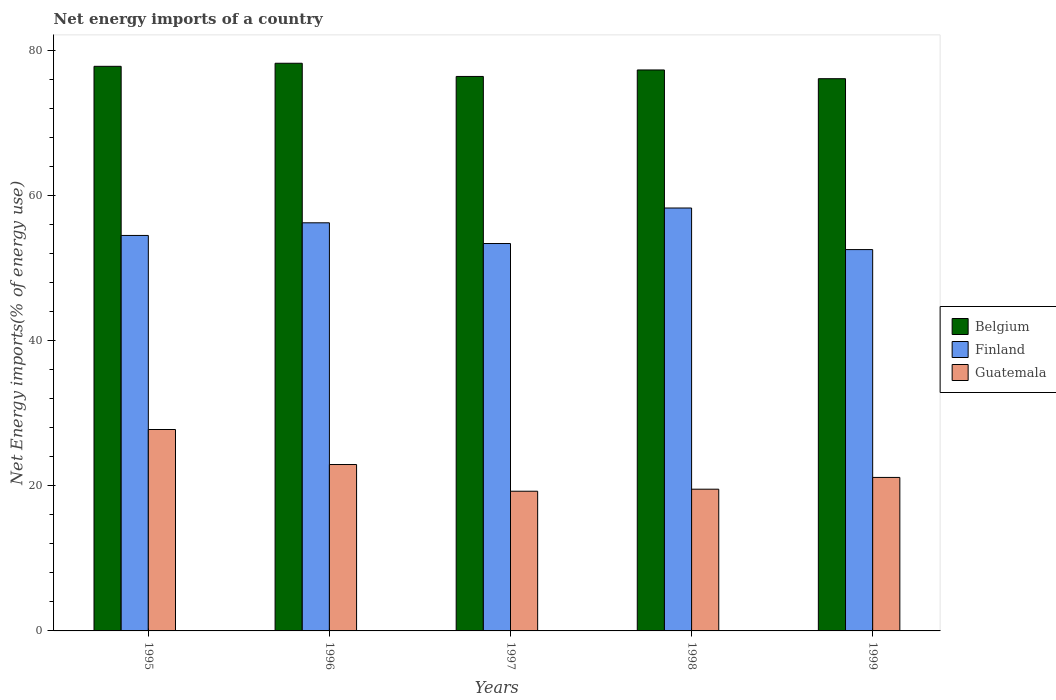Are the number of bars per tick equal to the number of legend labels?
Offer a terse response. Yes. Are the number of bars on each tick of the X-axis equal?
Offer a very short reply. Yes. How many bars are there on the 3rd tick from the left?
Offer a very short reply. 3. How many bars are there on the 5th tick from the right?
Provide a short and direct response. 3. What is the net energy imports in Guatemala in 1996?
Offer a terse response. 22.93. Across all years, what is the maximum net energy imports in Belgium?
Provide a succinct answer. 78.22. Across all years, what is the minimum net energy imports in Belgium?
Keep it short and to the point. 76.1. In which year was the net energy imports in Belgium maximum?
Ensure brevity in your answer.  1996. In which year was the net energy imports in Finland minimum?
Ensure brevity in your answer.  1999. What is the total net energy imports in Guatemala in the graph?
Your response must be concise. 110.61. What is the difference between the net energy imports in Finland in 1996 and that in 1997?
Offer a very short reply. 2.85. What is the difference between the net energy imports in Belgium in 1998 and the net energy imports in Finland in 1995?
Your answer should be compact. 22.8. What is the average net energy imports in Belgium per year?
Make the answer very short. 77.17. In the year 1998, what is the difference between the net energy imports in Guatemala and net energy imports in Belgium?
Provide a short and direct response. -57.77. In how many years, is the net energy imports in Finland greater than 64 %?
Provide a succinct answer. 0. What is the ratio of the net energy imports in Guatemala in 1998 to that in 1999?
Make the answer very short. 0.92. Is the net energy imports in Guatemala in 1997 less than that in 1998?
Provide a short and direct response. Yes. What is the difference between the highest and the second highest net energy imports in Guatemala?
Make the answer very short. 4.83. What is the difference between the highest and the lowest net energy imports in Belgium?
Your response must be concise. 2.13. Is it the case that in every year, the sum of the net energy imports in Belgium and net energy imports in Guatemala is greater than the net energy imports in Finland?
Give a very brief answer. Yes. Are all the bars in the graph horizontal?
Your response must be concise. No. How many years are there in the graph?
Make the answer very short. 5. What is the difference between two consecutive major ticks on the Y-axis?
Provide a short and direct response. 20. How many legend labels are there?
Provide a succinct answer. 3. What is the title of the graph?
Provide a succinct answer. Net energy imports of a country. What is the label or title of the X-axis?
Give a very brief answer. Years. What is the label or title of the Y-axis?
Make the answer very short. Net Energy imports(% of energy use). What is the Net Energy imports(% of energy use) of Belgium in 1995?
Give a very brief answer. 77.8. What is the Net Energy imports(% of energy use) in Finland in 1995?
Provide a short and direct response. 54.5. What is the Net Energy imports(% of energy use) of Guatemala in 1995?
Provide a succinct answer. 27.76. What is the Net Energy imports(% of energy use) in Belgium in 1996?
Your answer should be compact. 78.22. What is the Net Energy imports(% of energy use) of Finland in 1996?
Your answer should be compact. 56.24. What is the Net Energy imports(% of energy use) of Guatemala in 1996?
Your answer should be compact. 22.93. What is the Net Energy imports(% of energy use) in Belgium in 1997?
Give a very brief answer. 76.41. What is the Net Energy imports(% of energy use) in Finland in 1997?
Give a very brief answer. 53.38. What is the Net Energy imports(% of energy use) of Guatemala in 1997?
Keep it short and to the point. 19.25. What is the Net Energy imports(% of energy use) in Belgium in 1998?
Offer a terse response. 77.3. What is the Net Energy imports(% of energy use) in Finland in 1998?
Your answer should be very brief. 58.28. What is the Net Energy imports(% of energy use) of Guatemala in 1998?
Ensure brevity in your answer.  19.53. What is the Net Energy imports(% of energy use) of Belgium in 1999?
Offer a terse response. 76.1. What is the Net Energy imports(% of energy use) of Finland in 1999?
Make the answer very short. 52.55. What is the Net Energy imports(% of energy use) in Guatemala in 1999?
Offer a terse response. 21.15. Across all years, what is the maximum Net Energy imports(% of energy use) of Belgium?
Keep it short and to the point. 78.22. Across all years, what is the maximum Net Energy imports(% of energy use) of Finland?
Give a very brief answer. 58.28. Across all years, what is the maximum Net Energy imports(% of energy use) of Guatemala?
Your answer should be very brief. 27.76. Across all years, what is the minimum Net Energy imports(% of energy use) of Belgium?
Ensure brevity in your answer.  76.1. Across all years, what is the minimum Net Energy imports(% of energy use) of Finland?
Provide a succinct answer. 52.55. Across all years, what is the minimum Net Energy imports(% of energy use) of Guatemala?
Give a very brief answer. 19.25. What is the total Net Energy imports(% of energy use) in Belgium in the graph?
Ensure brevity in your answer.  385.83. What is the total Net Energy imports(% of energy use) of Finland in the graph?
Provide a short and direct response. 274.94. What is the total Net Energy imports(% of energy use) in Guatemala in the graph?
Offer a very short reply. 110.61. What is the difference between the Net Energy imports(% of energy use) of Belgium in 1995 and that in 1996?
Your response must be concise. -0.42. What is the difference between the Net Energy imports(% of energy use) in Finland in 1995 and that in 1996?
Provide a succinct answer. -1.74. What is the difference between the Net Energy imports(% of energy use) of Guatemala in 1995 and that in 1996?
Make the answer very short. 4.83. What is the difference between the Net Energy imports(% of energy use) in Belgium in 1995 and that in 1997?
Offer a terse response. 1.4. What is the difference between the Net Energy imports(% of energy use) of Finland in 1995 and that in 1997?
Offer a very short reply. 1.11. What is the difference between the Net Energy imports(% of energy use) in Guatemala in 1995 and that in 1997?
Your answer should be compact. 8.51. What is the difference between the Net Energy imports(% of energy use) in Belgium in 1995 and that in 1998?
Your answer should be very brief. 0.5. What is the difference between the Net Energy imports(% of energy use) in Finland in 1995 and that in 1998?
Provide a short and direct response. -3.78. What is the difference between the Net Energy imports(% of energy use) in Guatemala in 1995 and that in 1998?
Ensure brevity in your answer.  8.22. What is the difference between the Net Energy imports(% of energy use) in Belgium in 1995 and that in 1999?
Provide a succinct answer. 1.71. What is the difference between the Net Energy imports(% of energy use) in Finland in 1995 and that in 1999?
Provide a short and direct response. 1.95. What is the difference between the Net Energy imports(% of energy use) of Guatemala in 1995 and that in 1999?
Provide a short and direct response. 6.6. What is the difference between the Net Energy imports(% of energy use) of Belgium in 1996 and that in 1997?
Make the answer very short. 1.82. What is the difference between the Net Energy imports(% of energy use) of Finland in 1996 and that in 1997?
Provide a short and direct response. 2.85. What is the difference between the Net Energy imports(% of energy use) in Guatemala in 1996 and that in 1997?
Provide a succinct answer. 3.68. What is the difference between the Net Energy imports(% of energy use) in Belgium in 1996 and that in 1998?
Keep it short and to the point. 0.92. What is the difference between the Net Energy imports(% of energy use) of Finland in 1996 and that in 1998?
Offer a terse response. -2.04. What is the difference between the Net Energy imports(% of energy use) of Guatemala in 1996 and that in 1998?
Keep it short and to the point. 3.4. What is the difference between the Net Energy imports(% of energy use) in Belgium in 1996 and that in 1999?
Keep it short and to the point. 2.13. What is the difference between the Net Energy imports(% of energy use) of Finland in 1996 and that in 1999?
Ensure brevity in your answer.  3.69. What is the difference between the Net Energy imports(% of energy use) in Guatemala in 1996 and that in 1999?
Your response must be concise. 1.78. What is the difference between the Net Energy imports(% of energy use) in Belgium in 1997 and that in 1998?
Provide a succinct answer. -0.89. What is the difference between the Net Energy imports(% of energy use) of Finland in 1997 and that in 1998?
Offer a very short reply. -4.89. What is the difference between the Net Energy imports(% of energy use) in Guatemala in 1997 and that in 1998?
Offer a terse response. -0.28. What is the difference between the Net Energy imports(% of energy use) of Belgium in 1997 and that in 1999?
Your answer should be very brief. 0.31. What is the difference between the Net Energy imports(% of energy use) of Finland in 1997 and that in 1999?
Your answer should be compact. 0.84. What is the difference between the Net Energy imports(% of energy use) in Guatemala in 1997 and that in 1999?
Offer a very short reply. -1.9. What is the difference between the Net Energy imports(% of energy use) of Belgium in 1998 and that in 1999?
Your answer should be very brief. 1.2. What is the difference between the Net Energy imports(% of energy use) in Finland in 1998 and that in 1999?
Keep it short and to the point. 5.73. What is the difference between the Net Energy imports(% of energy use) of Guatemala in 1998 and that in 1999?
Provide a succinct answer. -1.62. What is the difference between the Net Energy imports(% of energy use) of Belgium in 1995 and the Net Energy imports(% of energy use) of Finland in 1996?
Make the answer very short. 21.57. What is the difference between the Net Energy imports(% of energy use) in Belgium in 1995 and the Net Energy imports(% of energy use) in Guatemala in 1996?
Make the answer very short. 54.87. What is the difference between the Net Energy imports(% of energy use) in Finland in 1995 and the Net Energy imports(% of energy use) in Guatemala in 1996?
Offer a terse response. 31.57. What is the difference between the Net Energy imports(% of energy use) of Belgium in 1995 and the Net Energy imports(% of energy use) of Finland in 1997?
Ensure brevity in your answer.  24.42. What is the difference between the Net Energy imports(% of energy use) of Belgium in 1995 and the Net Energy imports(% of energy use) of Guatemala in 1997?
Your answer should be compact. 58.55. What is the difference between the Net Energy imports(% of energy use) of Finland in 1995 and the Net Energy imports(% of energy use) of Guatemala in 1997?
Provide a succinct answer. 35.25. What is the difference between the Net Energy imports(% of energy use) in Belgium in 1995 and the Net Energy imports(% of energy use) in Finland in 1998?
Provide a short and direct response. 19.52. What is the difference between the Net Energy imports(% of energy use) in Belgium in 1995 and the Net Energy imports(% of energy use) in Guatemala in 1998?
Provide a succinct answer. 58.27. What is the difference between the Net Energy imports(% of energy use) of Finland in 1995 and the Net Energy imports(% of energy use) of Guatemala in 1998?
Your answer should be very brief. 34.97. What is the difference between the Net Energy imports(% of energy use) in Belgium in 1995 and the Net Energy imports(% of energy use) in Finland in 1999?
Your answer should be very brief. 25.25. What is the difference between the Net Energy imports(% of energy use) in Belgium in 1995 and the Net Energy imports(% of energy use) in Guatemala in 1999?
Your answer should be compact. 56.65. What is the difference between the Net Energy imports(% of energy use) of Finland in 1995 and the Net Energy imports(% of energy use) of Guatemala in 1999?
Keep it short and to the point. 33.35. What is the difference between the Net Energy imports(% of energy use) in Belgium in 1996 and the Net Energy imports(% of energy use) in Finland in 1997?
Your answer should be compact. 24.84. What is the difference between the Net Energy imports(% of energy use) of Belgium in 1996 and the Net Energy imports(% of energy use) of Guatemala in 1997?
Your response must be concise. 58.97. What is the difference between the Net Energy imports(% of energy use) in Finland in 1996 and the Net Energy imports(% of energy use) in Guatemala in 1997?
Give a very brief answer. 36.99. What is the difference between the Net Energy imports(% of energy use) in Belgium in 1996 and the Net Energy imports(% of energy use) in Finland in 1998?
Ensure brevity in your answer.  19.95. What is the difference between the Net Energy imports(% of energy use) of Belgium in 1996 and the Net Energy imports(% of energy use) of Guatemala in 1998?
Ensure brevity in your answer.  58.69. What is the difference between the Net Energy imports(% of energy use) in Finland in 1996 and the Net Energy imports(% of energy use) in Guatemala in 1998?
Give a very brief answer. 36.71. What is the difference between the Net Energy imports(% of energy use) in Belgium in 1996 and the Net Energy imports(% of energy use) in Finland in 1999?
Offer a terse response. 25.68. What is the difference between the Net Energy imports(% of energy use) in Belgium in 1996 and the Net Energy imports(% of energy use) in Guatemala in 1999?
Give a very brief answer. 57.07. What is the difference between the Net Energy imports(% of energy use) in Finland in 1996 and the Net Energy imports(% of energy use) in Guatemala in 1999?
Provide a short and direct response. 35.09. What is the difference between the Net Energy imports(% of energy use) in Belgium in 1997 and the Net Energy imports(% of energy use) in Finland in 1998?
Give a very brief answer. 18.13. What is the difference between the Net Energy imports(% of energy use) in Belgium in 1997 and the Net Energy imports(% of energy use) in Guatemala in 1998?
Your response must be concise. 56.88. What is the difference between the Net Energy imports(% of energy use) in Finland in 1997 and the Net Energy imports(% of energy use) in Guatemala in 1998?
Provide a short and direct response. 33.85. What is the difference between the Net Energy imports(% of energy use) in Belgium in 1997 and the Net Energy imports(% of energy use) in Finland in 1999?
Keep it short and to the point. 23.86. What is the difference between the Net Energy imports(% of energy use) of Belgium in 1997 and the Net Energy imports(% of energy use) of Guatemala in 1999?
Provide a succinct answer. 55.26. What is the difference between the Net Energy imports(% of energy use) in Finland in 1997 and the Net Energy imports(% of energy use) in Guatemala in 1999?
Keep it short and to the point. 32.23. What is the difference between the Net Energy imports(% of energy use) of Belgium in 1998 and the Net Energy imports(% of energy use) of Finland in 1999?
Give a very brief answer. 24.75. What is the difference between the Net Energy imports(% of energy use) in Belgium in 1998 and the Net Energy imports(% of energy use) in Guatemala in 1999?
Keep it short and to the point. 56.15. What is the difference between the Net Energy imports(% of energy use) of Finland in 1998 and the Net Energy imports(% of energy use) of Guatemala in 1999?
Make the answer very short. 37.13. What is the average Net Energy imports(% of energy use) of Belgium per year?
Keep it short and to the point. 77.17. What is the average Net Energy imports(% of energy use) of Finland per year?
Make the answer very short. 54.99. What is the average Net Energy imports(% of energy use) of Guatemala per year?
Ensure brevity in your answer.  22.12. In the year 1995, what is the difference between the Net Energy imports(% of energy use) in Belgium and Net Energy imports(% of energy use) in Finland?
Your answer should be very brief. 23.31. In the year 1995, what is the difference between the Net Energy imports(% of energy use) of Belgium and Net Energy imports(% of energy use) of Guatemala?
Offer a terse response. 50.05. In the year 1995, what is the difference between the Net Energy imports(% of energy use) of Finland and Net Energy imports(% of energy use) of Guatemala?
Make the answer very short. 26.74. In the year 1996, what is the difference between the Net Energy imports(% of energy use) in Belgium and Net Energy imports(% of energy use) in Finland?
Ensure brevity in your answer.  21.99. In the year 1996, what is the difference between the Net Energy imports(% of energy use) of Belgium and Net Energy imports(% of energy use) of Guatemala?
Provide a short and direct response. 55.29. In the year 1996, what is the difference between the Net Energy imports(% of energy use) in Finland and Net Energy imports(% of energy use) in Guatemala?
Provide a succinct answer. 33.31. In the year 1997, what is the difference between the Net Energy imports(% of energy use) in Belgium and Net Energy imports(% of energy use) in Finland?
Ensure brevity in your answer.  23.02. In the year 1997, what is the difference between the Net Energy imports(% of energy use) of Belgium and Net Energy imports(% of energy use) of Guatemala?
Your answer should be compact. 57.16. In the year 1997, what is the difference between the Net Energy imports(% of energy use) in Finland and Net Energy imports(% of energy use) in Guatemala?
Provide a short and direct response. 34.13. In the year 1998, what is the difference between the Net Energy imports(% of energy use) of Belgium and Net Energy imports(% of energy use) of Finland?
Ensure brevity in your answer.  19.02. In the year 1998, what is the difference between the Net Energy imports(% of energy use) of Belgium and Net Energy imports(% of energy use) of Guatemala?
Provide a short and direct response. 57.77. In the year 1998, what is the difference between the Net Energy imports(% of energy use) in Finland and Net Energy imports(% of energy use) in Guatemala?
Make the answer very short. 38.75. In the year 1999, what is the difference between the Net Energy imports(% of energy use) of Belgium and Net Energy imports(% of energy use) of Finland?
Ensure brevity in your answer.  23.55. In the year 1999, what is the difference between the Net Energy imports(% of energy use) of Belgium and Net Energy imports(% of energy use) of Guatemala?
Make the answer very short. 54.95. In the year 1999, what is the difference between the Net Energy imports(% of energy use) of Finland and Net Energy imports(% of energy use) of Guatemala?
Your response must be concise. 31.4. What is the ratio of the Net Energy imports(% of energy use) of Belgium in 1995 to that in 1996?
Give a very brief answer. 0.99. What is the ratio of the Net Energy imports(% of energy use) in Finland in 1995 to that in 1996?
Offer a very short reply. 0.97. What is the ratio of the Net Energy imports(% of energy use) in Guatemala in 1995 to that in 1996?
Give a very brief answer. 1.21. What is the ratio of the Net Energy imports(% of energy use) in Belgium in 1995 to that in 1997?
Ensure brevity in your answer.  1.02. What is the ratio of the Net Energy imports(% of energy use) of Finland in 1995 to that in 1997?
Your answer should be very brief. 1.02. What is the ratio of the Net Energy imports(% of energy use) of Guatemala in 1995 to that in 1997?
Give a very brief answer. 1.44. What is the ratio of the Net Energy imports(% of energy use) of Belgium in 1995 to that in 1998?
Provide a succinct answer. 1.01. What is the ratio of the Net Energy imports(% of energy use) of Finland in 1995 to that in 1998?
Your response must be concise. 0.94. What is the ratio of the Net Energy imports(% of energy use) in Guatemala in 1995 to that in 1998?
Your response must be concise. 1.42. What is the ratio of the Net Energy imports(% of energy use) in Belgium in 1995 to that in 1999?
Offer a terse response. 1.02. What is the ratio of the Net Energy imports(% of energy use) in Finland in 1995 to that in 1999?
Offer a terse response. 1.04. What is the ratio of the Net Energy imports(% of energy use) of Guatemala in 1995 to that in 1999?
Provide a short and direct response. 1.31. What is the ratio of the Net Energy imports(% of energy use) in Belgium in 1996 to that in 1997?
Offer a terse response. 1.02. What is the ratio of the Net Energy imports(% of energy use) of Finland in 1996 to that in 1997?
Make the answer very short. 1.05. What is the ratio of the Net Energy imports(% of energy use) in Guatemala in 1996 to that in 1997?
Your response must be concise. 1.19. What is the ratio of the Net Energy imports(% of energy use) of Belgium in 1996 to that in 1998?
Offer a terse response. 1.01. What is the ratio of the Net Energy imports(% of energy use) in Guatemala in 1996 to that in 1998?
Offer a very short reply. 1.17. What is the ratio of the Net Energy imports(% of energy use) of Belgium in 1996 to that in 1999?
Offer a very short reply. 1.03. What is the ratio of the Net Energy imports(% of energy use) in Finland in 1996 to that in 1999?
Make the answer very short. 1.07. What is the ratio of the Net Energy imports(% of energy use) in Guatemala in 1996 to that in 1999?
Keep it short and to the point. 1.08. What is the ratio of the Net Energy imports(% of energy use) in Belgium in 1997 to that in 1998?
Provide a short and direct response. 0.99. What is the ratio of the Net Energy imports(% of energy use) in Finland in 1997 to that in 1998?
Ensure brevity in your answer.  0.92. What is the ratio of the Net Energy imports(% of energy use) in Guatemala in 1997 to that in 1998?
Your answer should be compact. 0.99. What is the ratio of the Net Energy imports(% of energy use) of Belgium in 1997 to that in 1999?
Your response must be concise. 1. What is the ratio of the Net Energy imports(% of energy use) of Finland in 1997 to that in 1999?
Provide a succinct answer. 1.02. What is the ratio of the Net Energy imports(% of energy use) in Guatemala in 1997 to that in 1999?
Give a very brief answer. 0.91. What is the ratio of the Net Energy imports(% of energy use) of Belgium in 1998 to that in 1999?
Provide a succinct answer. 1.02. What is the ratio of the Net Energy imports(% of energy use) of Finland in 1998 to that in 1999?
Ensure brevity in your answer.  1.11. What is the ratio of the Net Energy imports(% of energy use) of Guatemala in 1998 to that in 1999?
Keep it short and to the point. 0.92. What is the difference between the highest and the second highest Net Energy imports(% of energy use) in Belgium?
Your answer should be compact. 0.42. What is the difference between the highest and the second highest Net Energy imports(% of energy use) of Finland?
Provide a succinct answer. 2.04. What is the difference between the highest and the second highest Net Energy imports(% of energy use) in Guatemala?
Offer a terse response. 4.83. What is the difference between the highest and the lowest Net Energy imports(% of energy use) in Belgium?
Your response must be concise. 2.13. What is the difference between the highest and the lowest Net Energy imports(% of energy use) of Finland?
Make the answer very short. 5.73. What is the difference between the highest and the lowest Net Energy imports(% of energy use) of Guatemala?
Your response must be concise. 8.51. 